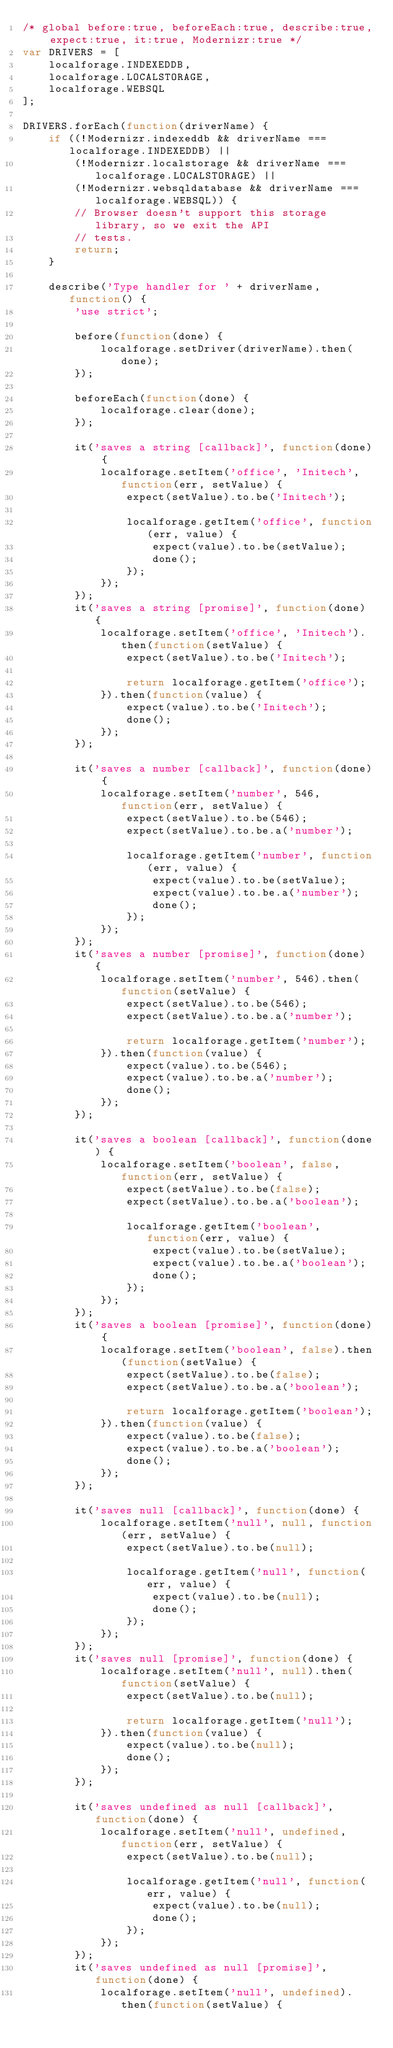<code> <loc_0><loc_0><loc_500><loc_500><_JavaScript_>/* global before:true, beforeEach:true, describe:true, expect:true, it:true, Modernizr:true */
var DRIVERS = [
    localforage.INDEXEDDB,
    localforage.LOCALSTORAGE,
    localforage.WEBSQL
];

DRIVERS.forEach(function(driverName) {
    if ((!Modernizr.indexeddb && driverName === localforage.INDEXEDDB) ||
        (!Modernizr.localstorage && driverName === localforage.LOCALSTORAGE) ||
        (!Modernizr.websqldatabase && driverName === localforage.WEBSQL)) {
        // Browser doesn't support this storage library, so we exit the API
        // tests.
        return;
    }

    describe('Type handler for ' + driverName, function() {
        'use strict';

        before(function(done) {
            localforage.setDriver(driverName).then(done);
        });

        beforeEach(function(done) {
            localforage.clear(done);
        });

        it('saves a string [callback]', function(done) {
            localforage.setItem('office', 'Initech', function(err, setValue) {
                expect(setValue).to.be('Initech');

                localforage.getItem('office', function(err, value) {
                    expect(value).to.be(setValue);
                    done();
                });
            });
        });
        it('saves a string [promise]', function(done) {
            localforage.setItem('office', 'Initech').then(function(setValue) {
                expect(setValue).to.be('Initech');

                return localforage.getItem('office');
            }).then(function(value) {
                expect(value).to.be('Initech');
                done();
            });
        });

        it('saves a number [callback]', function(done) {
            localforage.setItem('number', 546, function(err, setValue) {
                expect(setValue).to.be(546);
                expect(setValue).to.be.a('number');

                localforage.getItem('number', function(err, value) {
                    expect(value).to.be(setValue);
                    expect(value).to.be.a('number');
                    done();
                });
            });
        });
        it('saves a number [promise]', function(done) {
            localforage.setItem('number', 546).then(function(setValue) {
                expect(setValue).to.be(546);
                expect(setValue).to.be.a('number');

                return localforage.getItem('number');
            }).then(function(value) {
                expect(value).to.be(546);
                expect(value).to.be.a('number');
                done();
            });
        });

        it('saves a boolean [callback]', function(done) {
            localforage.setItem('boolean', false, function(err, setValue) {
                expect(setValue).to.be(false);
                expect(setValue).to.be.a('boolean');

                localforage.getItem('boolean', function(err, value) {
                    expect(value).to.be(setValue);
                    expect(value).to.be.a('boolean');
                    done();
                });
            });
        });
        it('saves a boolean [promise]', function(done) {
            localforage.setItem('boolean', false).then(function(setValue) {
                expect(setValue).to.be(false);
                expect(setValue).to.be.a('boolean');

                return localforage.getItem('boolean');
            }).then(function(value) {
                expect(value).to.be(false);
                expect(value).to.be.a('boolean');
                done();
            });
        });

        it('saves null [callback]', function(done) {
            localforage.setItem('null', null, function(err, setValue) {
                expect(setValue).to.be(null);

                localforage.getItem('null', function(err, value) {
                    expect(value).to.be(null);
                    done();
                });
            });
        });
        it('saves null [promise]', function(done) {
            localforage.setItem('null', null).then(function(setValue) {
                expect(setValue).to.be(null);

                return localforage.getItem('null');
            }).then(function(value) {
                expect(value).to.be(null);
                done();
            });
        });

        it('saves undefined as null [callback]', function(done) {
            localforage.setItem('null', undefined, function(err, setValue) {
                expect(setValue).to.be(null);

                localforage.getItem('null', function(err, value) {
                    expect(value).to.be(null);
                    done();
                });
            });
        });
        it('saves undefined as null [promise]', function(done) {
            localforage.setItem('null', undefined).then(function(setValue) {</code> 